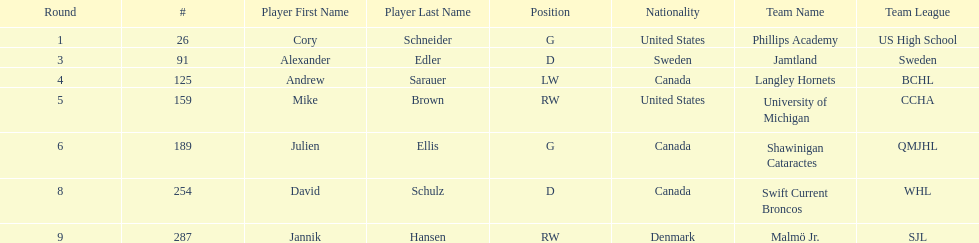Which player has canadian nationality and attended langley hornets? Andrew Sarauer (LW). 